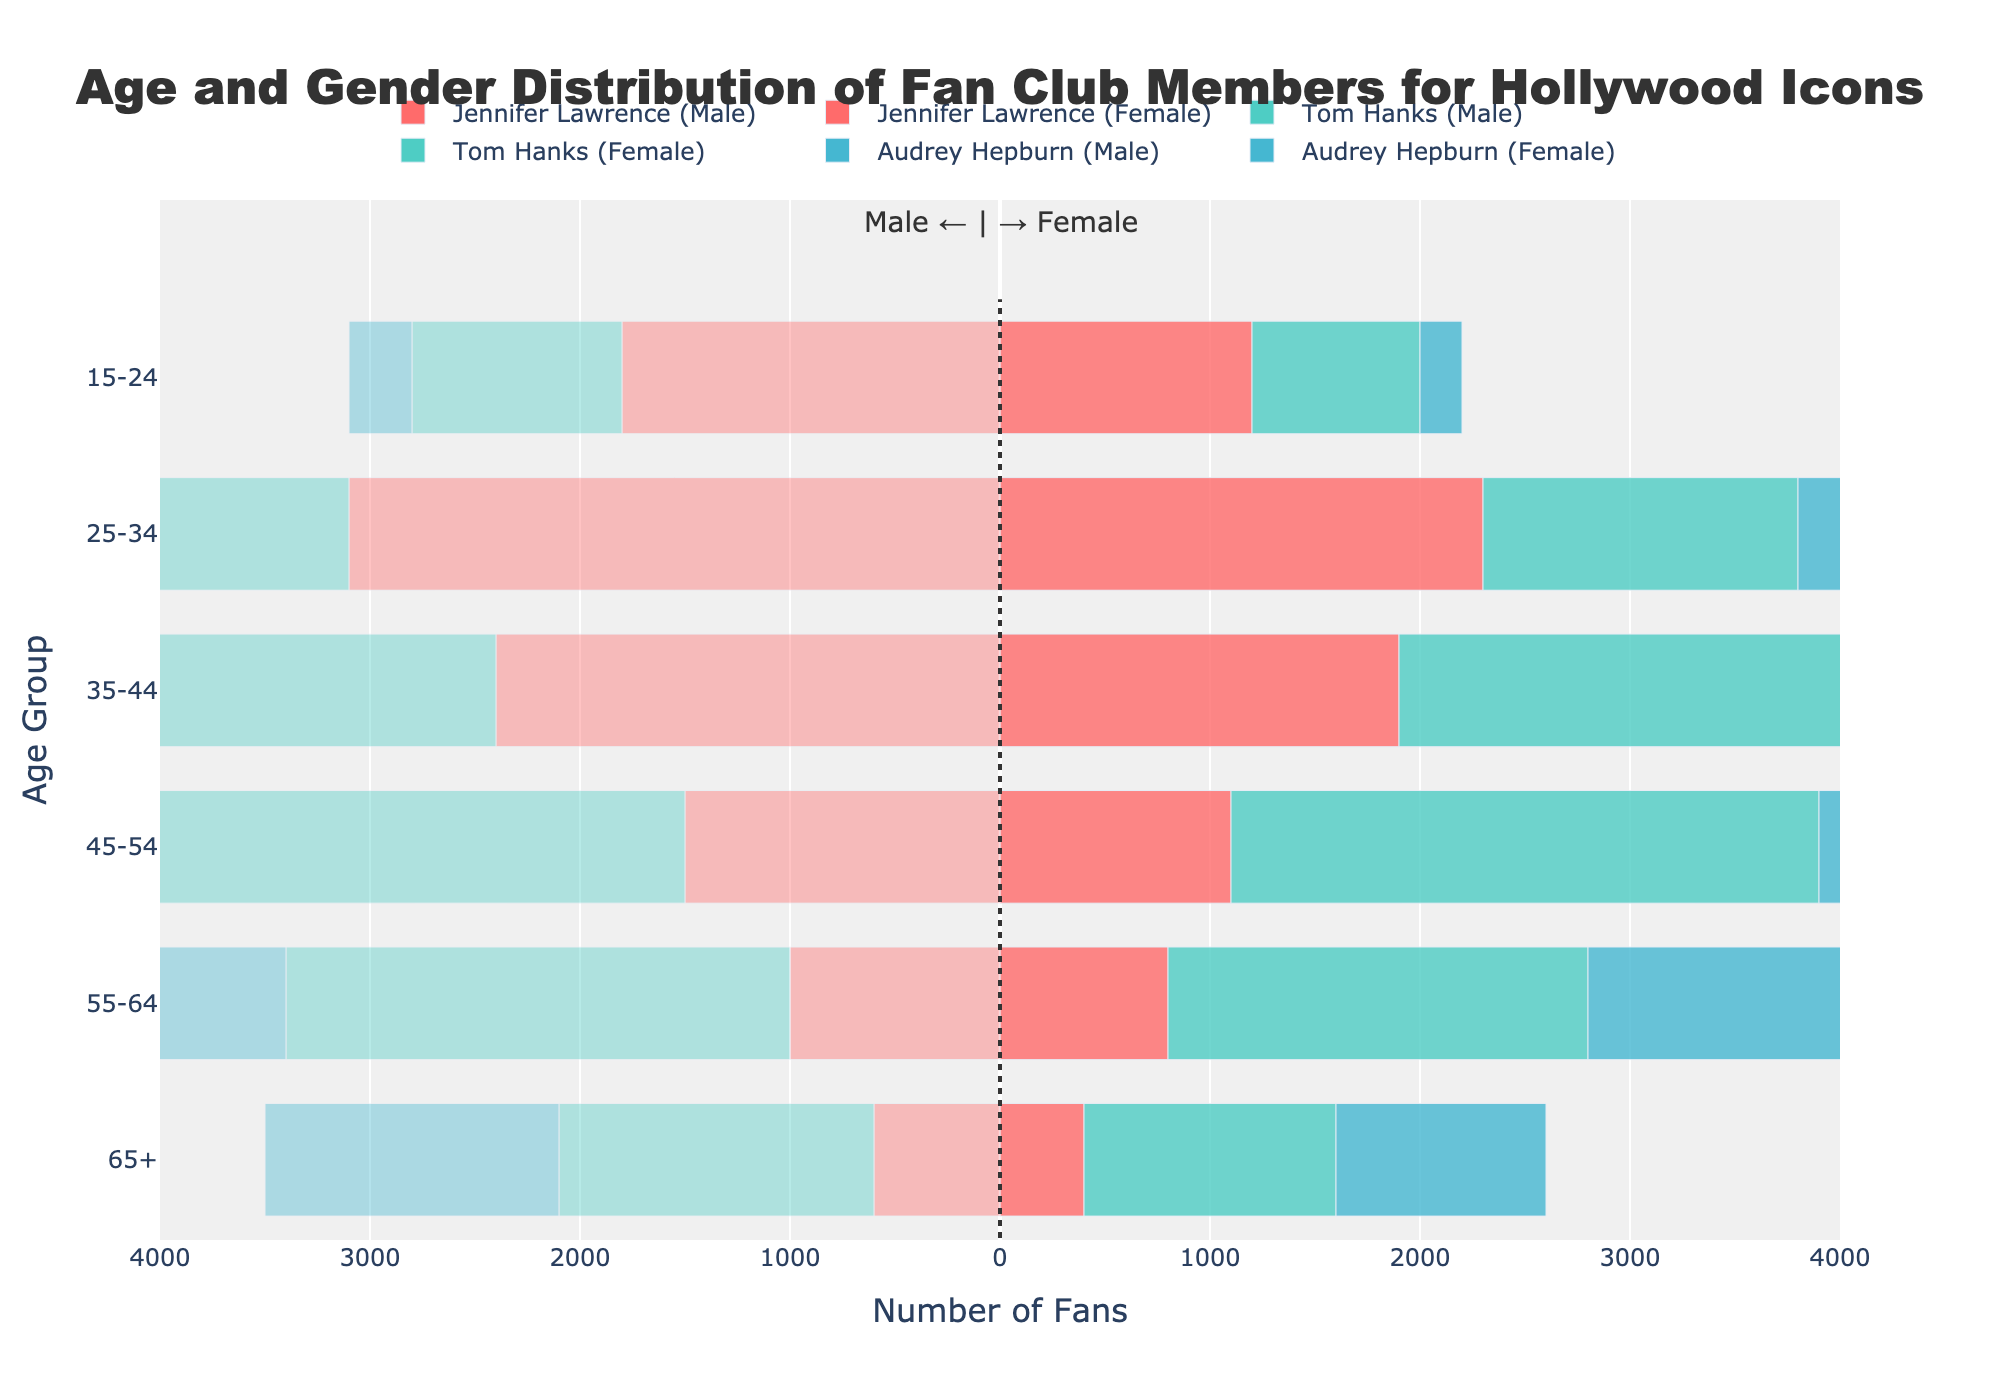Which Hollywood icon has the highest number of fans in the 25-34 age group? To determine this, look at the data bars for each icon (Jennifer Lawrence, Tom Hanks, Audrey Hepburn) for the 25-34 age group. Compare the longest bar lengths (merged bars for both male and female fans). Jennifer Lawrence has 2300+3100 fans, Tom Hanks has 1500+1800 fans, and Audrey Hepburn has 400+600 fans. Jennifer Lawrence's bar is the longest.
Answer: Jennifer Lawrence Among Tom Hanks' fans, which gender is more dominant overall? Sum male and female fans across all age groups for Tom Hanks. Males: 800+1500+2200+2800+2000+1200=10500; Females: 1000+1800+2600+3200+2400+1500=12500. Females have a higher total count.
Answer: Female Which age group of Audrey Hepburn has the least fans? Examine the bars for Audrey Hepburn in each age group and find the smallest total combined from male and female sections. The 15-24 age group with 200+300=500 fans is the least.
Answer: 15-24 How many more fans aged 45-54 does Jennifer Lawrence have compared to Audrey Hepburn? Look at 45-54 for both icons. Jennifer Lawrence: 1100+1500=2600, Audrey Hepburn: 1500+2000=3500. Difference is 3500-2600.
Answer: 900 more Which Hollywood icon has the most fans in the 65+ age group? Examine the bars at the 65+ age group. Jennifer Lawrence: 400+600=1000, Tom Hanks: 1200+1500=2700, Audrey Hepburn: 1000+1400=2400. Tom Hanks' combined fans are highest.
Answer: Tom Hanks For the 35-44 age group, how many total fans does Tom Hanks have more than Jennifer Lawrence? Sum fans for the 35-44 age group for both icons. Tom Hanks: 2200+2600=4800, Jennifer Lawrence: 1900+2400=4300. Difference is 4800-4300.
Answer: 500 more In which age group does Jennifer Lawrence have the largest difference in the number of male and female fans? Assess the difference between male and female fans for each age group Jennifer Lawrence falls into. Differences: 15-24: 600, 25-34: 800, 35-44: 500, 45-54: 400, 55-64: 200, 65+: 200. The 25-34 age group has the largest difference.
Answer: 25-34 